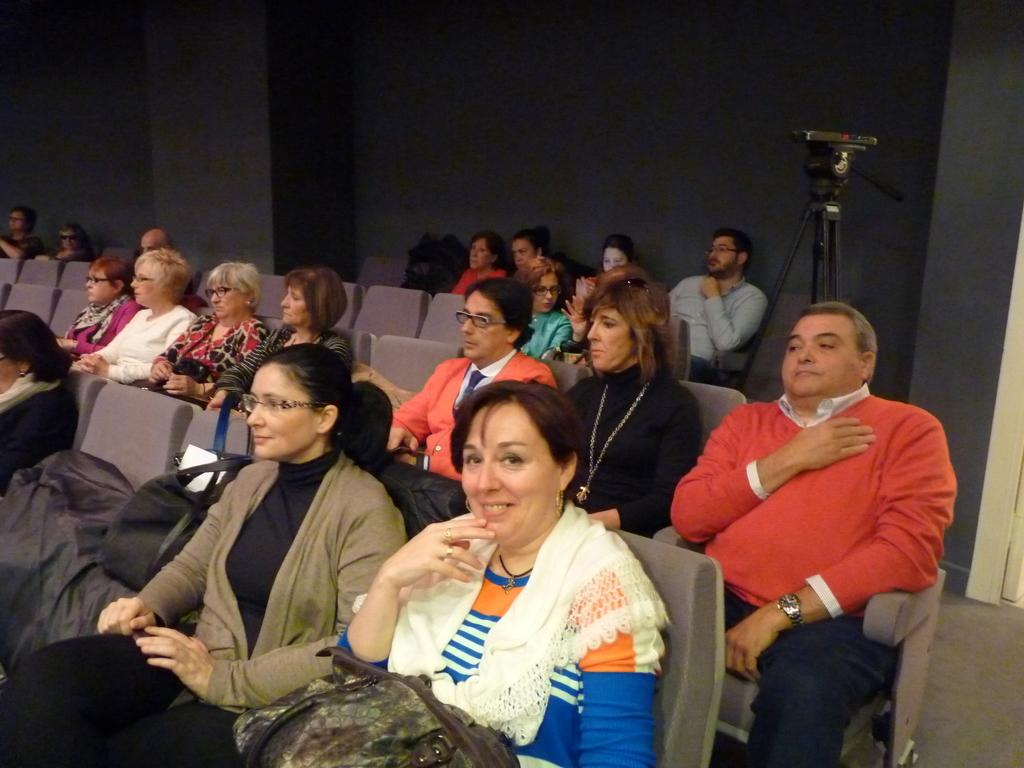What are the people in the image doing? The people in the image are sitting on chairs. What object is visible in the image that is typically used for capturing images? There is a camera visible in the image. What type of structure can be seen in the image? There is a wall in the image. Where is the baby located in the image? There is no baby present in the image. What type of container is visible in the image? There is no crate present in the image. What type of device is visible in the image that is typically used for performing calculations? There is no calculator present in the image. 